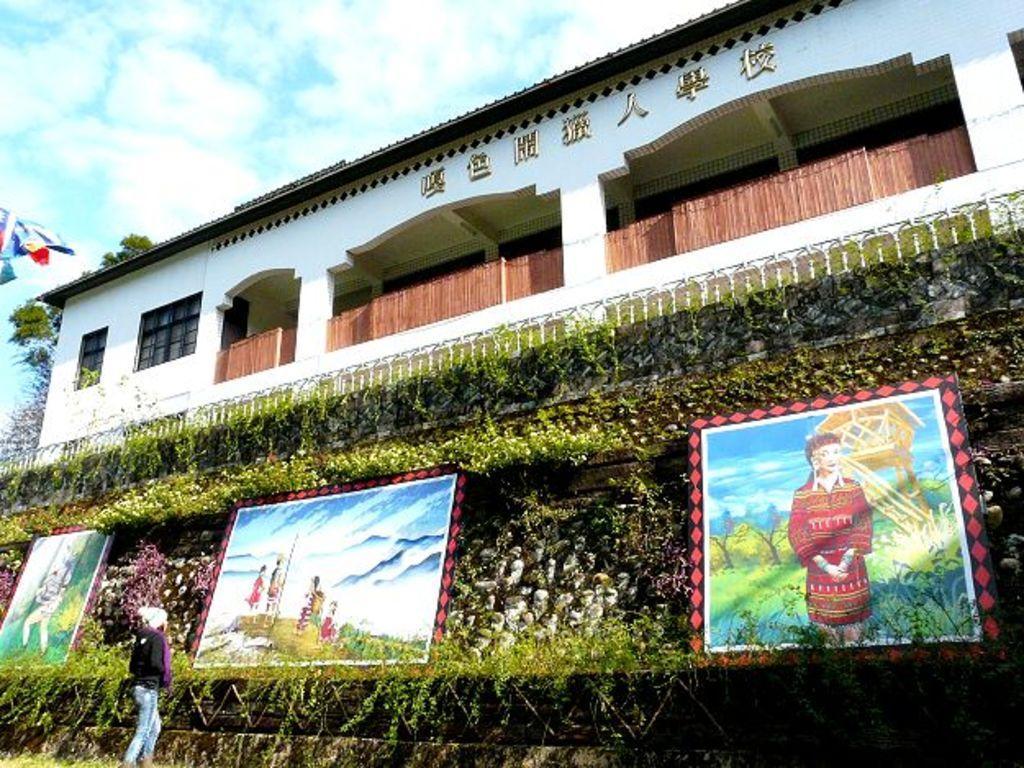In one or two sentences, can you explain what this image depicts? In this picture I can see a building and few plants and trees and I can see few painted photo frames and I can see a woman standing and watching and I can see couple of flags and a cloudy sky. 